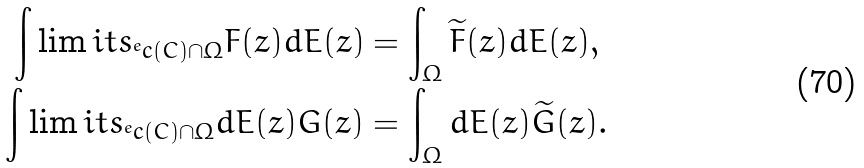<formula> <loc_0><loc_0><loc_500><loc_500>\int \lim i t s _ { ^ { e } c ( C ) \cap \Omega } F ( z ) d E ( z ) & = \int _ { \Omega } \widetilde { F } ( z ) d E ( z ) , \\ \int \lim i t s _ { ^ { e } c ( C ) \cap \Omega } d E ( z ) G ( z ) & = \int _ { \Omega } d E ( z ) \widetilde { G } ( z ) .</formula> 